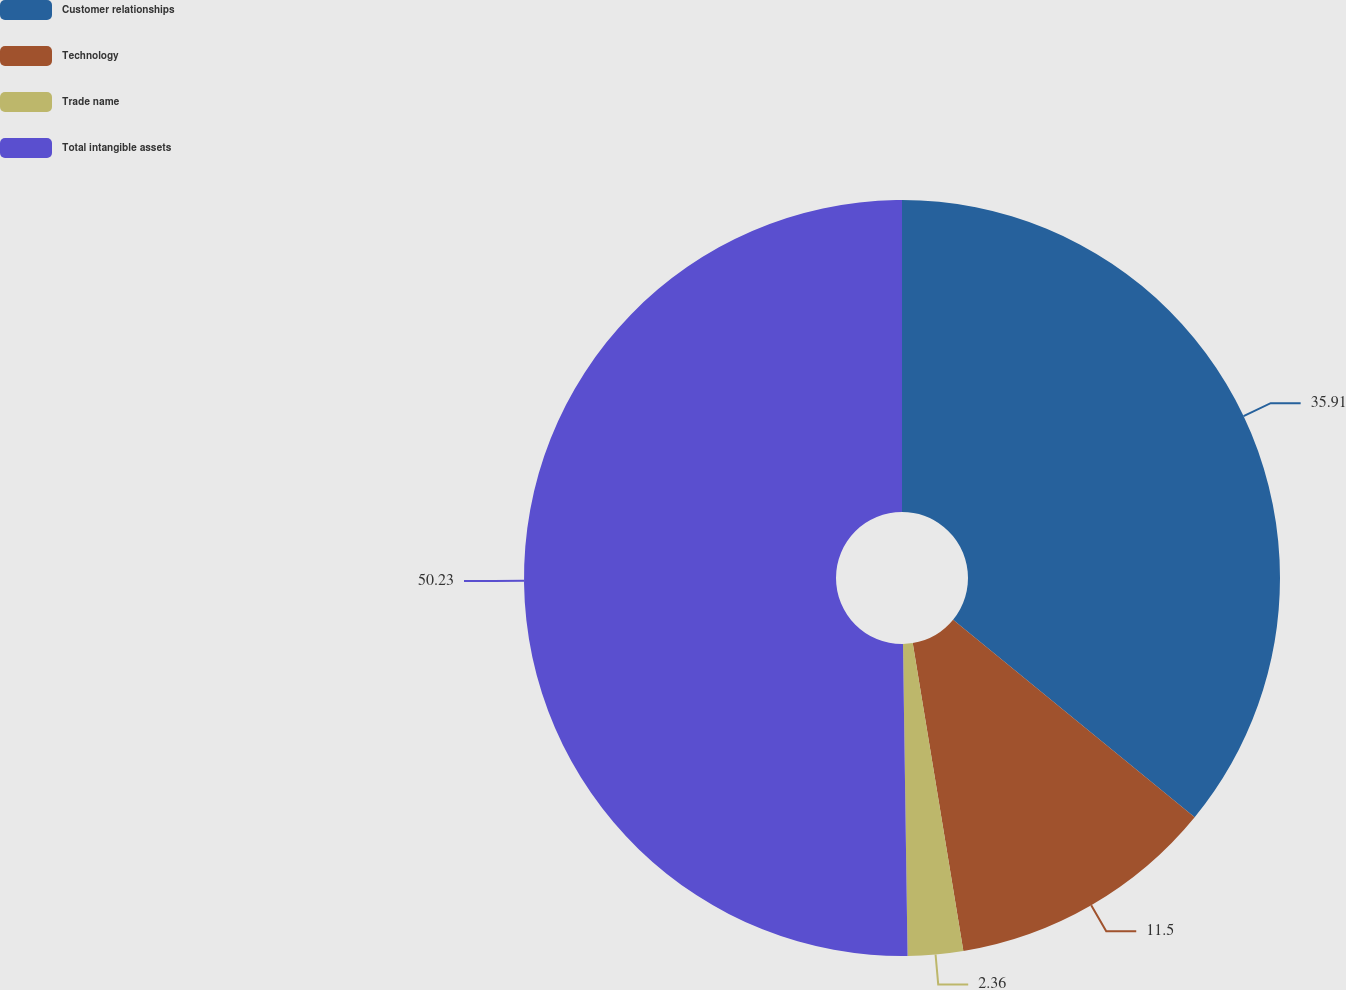Convert chart to OTSL. <chart><loc_0><loc_0><loc_500><loc_500><pie_chart><fcel>Customer relationships<fcel>Technology<fcel>Trade name<fcel>Total intangible assets<nl><fcel>35.91%<fcel>11.5%<fcel>2.36%<fcel>50.24%<nl></chart> 